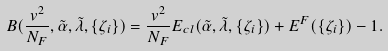Convert formula to latex. <formula><loc_0><loc_0><loc_500><loc_500>B ( \frac { v ^ { 2 } } { N _ { F } } , \tilde { \alpha } , \tilde { \lambda } , \{ \zeta _ { i } \} ) = \frac { v ^ { 2 } } { N _ { F } } E _ { c l } ( \tilde { \alpha } , \tilde { \lambda } , \{ \zeta _ { i } \} ) + E ^ { F } ( \{ \zeta _ { i } \} ) - 1 .</formula> 